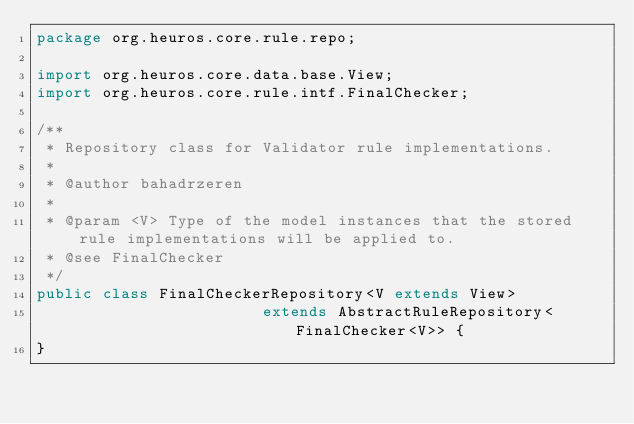<code> <loc_0><loc_0><loc_500><loc_500><_Java_>package org.heuros.core.rule.repo;

import org.heuros.core.data.base.View;
import org.heuros.core.rule.intf.FinalChecker;

/**
 * Repository class for Validator rule implementations.
 * 
 * @author bahadrzeren
 *
 * @param <V> Type of the model instances that the stored rule implementations will be applied to.
 * @see FinalChecker
 */
public class FinalCheckerRepository<V extends View>
						extends AbstractRuleRepository<FinalChecker<V>> {
}
</code> 